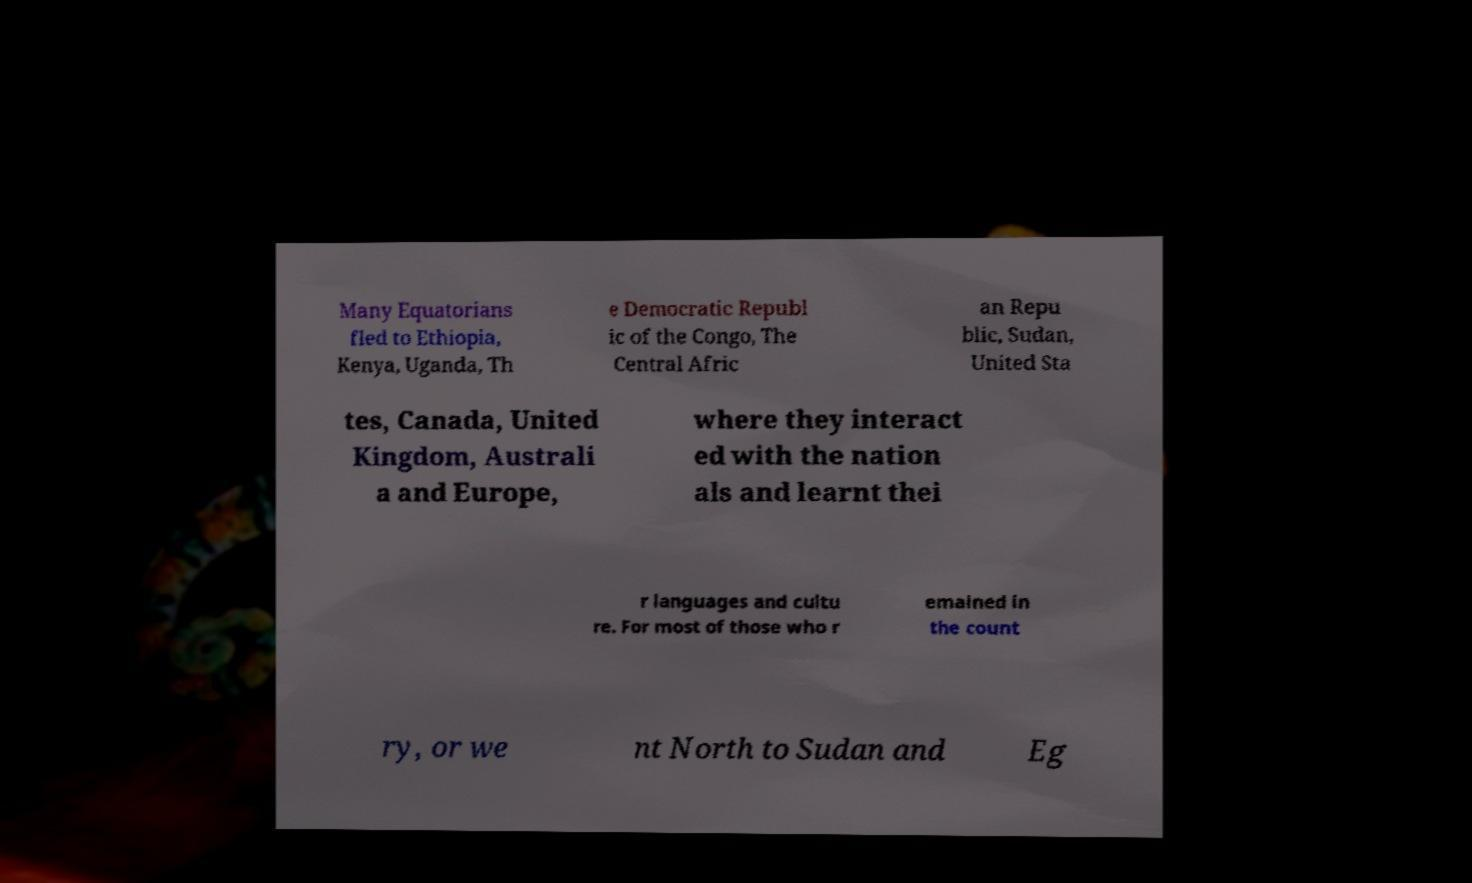I need the written content from this picture converted into text. Can you do that? Many Equatorians fled to Ethiopia, Kenya, Uganda, Th e Democratic Republ ic of the Congo, The Central Afric an Repu blic, Sudan, United Sta tes, Canada, United Kingdom, Australi a and Europe, where they interact ed with the nation als and learnt thei r languages and cultu re. For most of those who r emained in the count ry, or we nt North to Sudan and Eg 